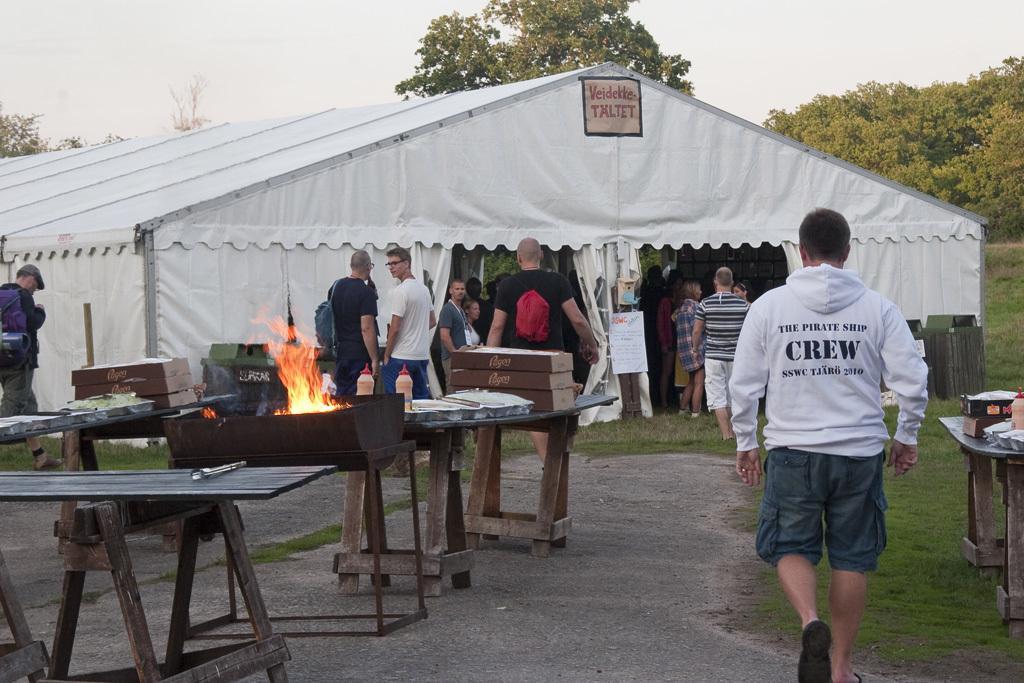Please provide a concise description of this image. We have a tent on which there are a group of people and in front of the rent we have some wooden tables and some people out side the tent. 